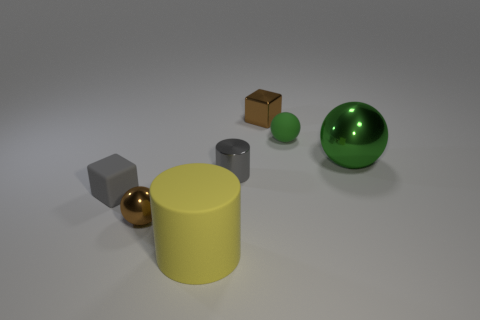How many green balls must be subtracted to get 1 green balls? 1 Add 3 small green matte things. How many objects exist? 10 Subtract all balls. How many objects are left? 4 Subtract 0 purple cubes. How many objects are left? 7 Subtract all tiny brown rubber balls. Subtract all shiny cubes. How many objects are left? 6 Add 1 green metal objects. How many green metal objects are left? 2 Add 3 small spheres. How many small spheres exist? 5 